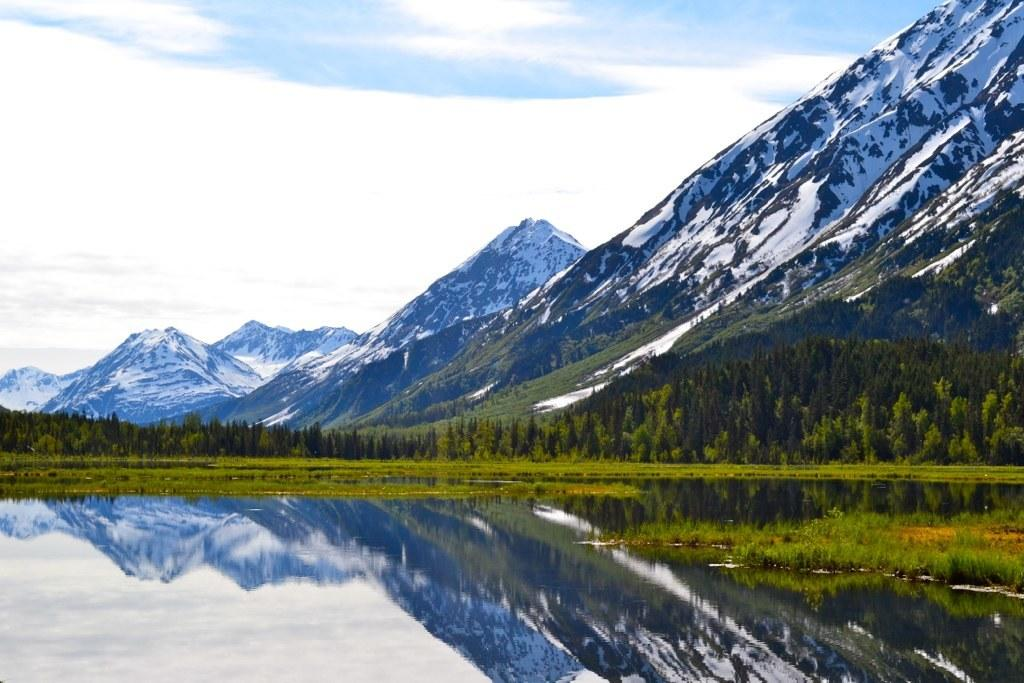What is the primary element in the image? There is water in the image. What type of vegetation is present on the ground? Grass is present on the ground. What other natural elements can be seen in the image? Trees are visible in the image. What is the landscape feature in the background? There are snow mountains in the background. What is the condition of the sky in the image? Clouds are present in the sky, and the sky is blue. What book is the person reading in the image? There is no person or book present in the image; it features water, grass, trees, snow mountains, clouds, and a blue sky. 